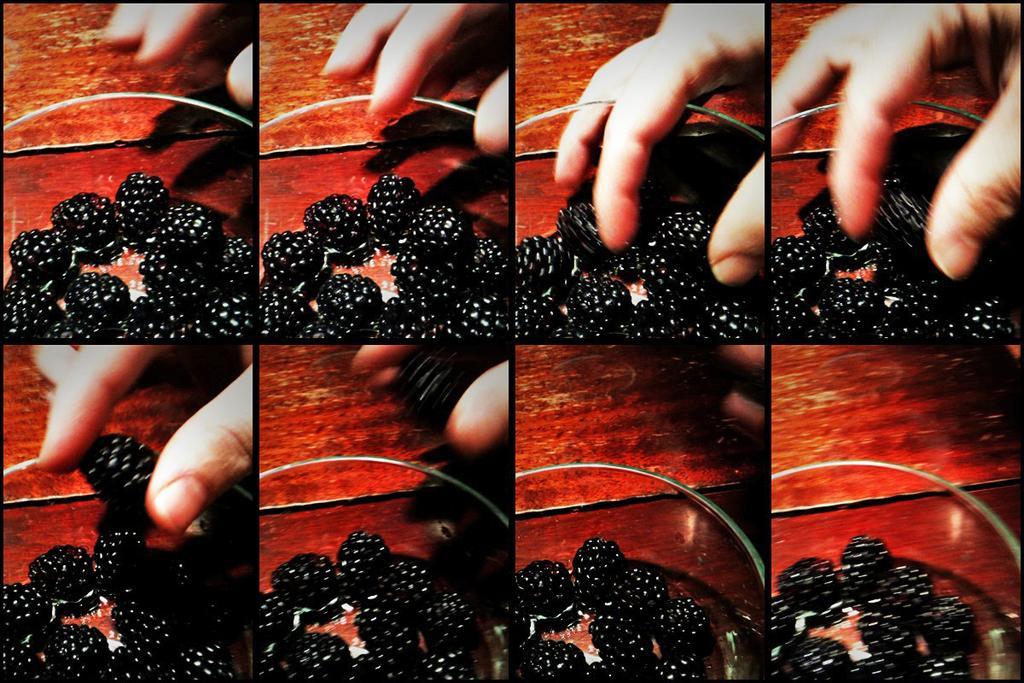Can you describe this image briefly? This is a collage image. In this image we can see a person holding berries placed in the bowl. 